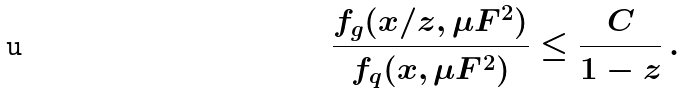Convert formula to latex. <formula><loc_0><loc_0><loc_500><loc_500>\frac { f _ { g } ( x / z , \mu F ^ { 2 } ) } { f _ { q } ( x , \mu F ^ { 2 } ) } \leq \frac { C } { 1 - z } \, .</formula> 